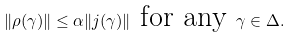Convert formula to latex. <formula><loc_0><loc_0><loc_500><loc_500>\| \rho ( \gamma ) \| \leq \alpha \| j ( \gamma ) \| \text { for any } \gamma \in \Delta .</formula> 